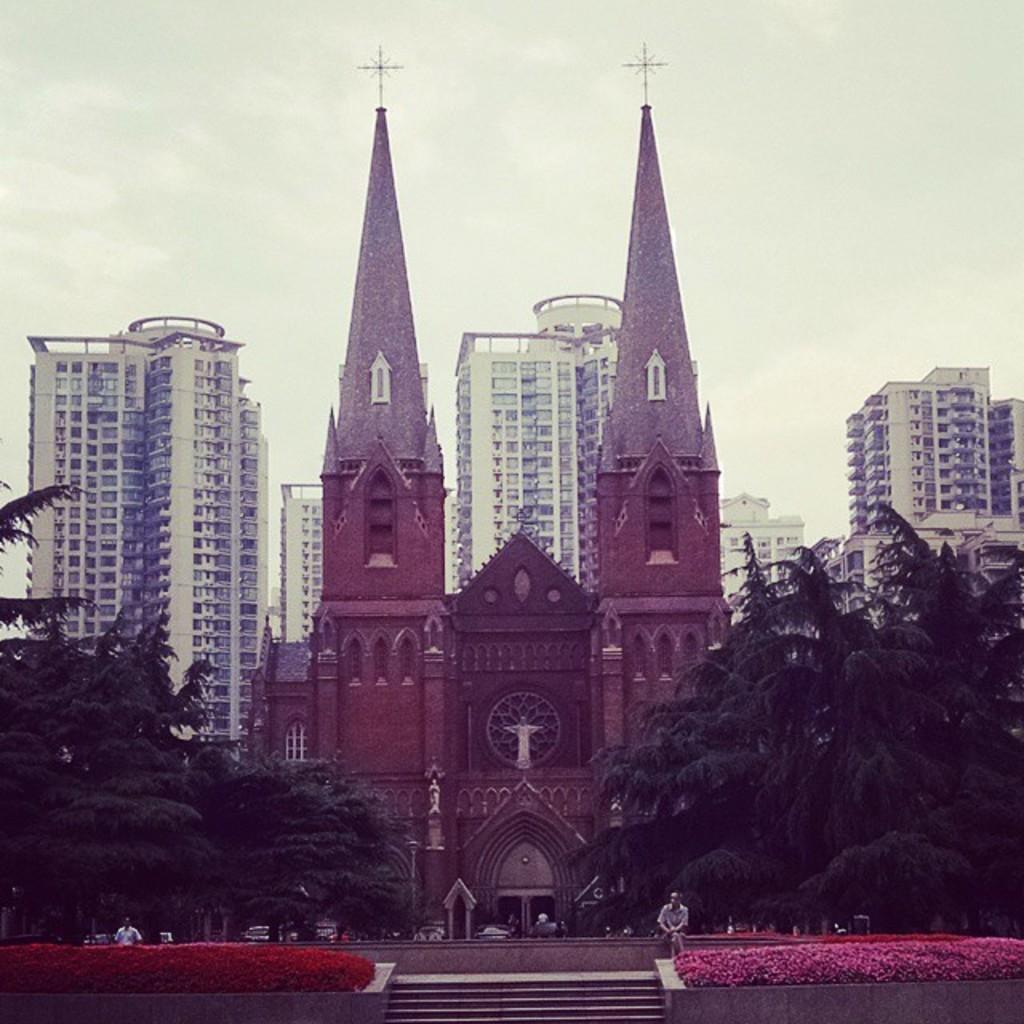What type of natural elements can be seen in the image? There are flowers and trees in the image. Are there any human subjects in the image? Yes, there are people in the image. What type of man-made structures are visible in the image? There are buildings in the image. Can you describe the position of a person in the image? There is a person seated in front of a building in the image. What type of whip is being used to trim the flowers in the image? There is no whip present in the image, and the flowers are not being trimmed. What type of beam is supporting the trees in the image? There is no beam present in the image, and the trees are not being supported by any visible structure. 